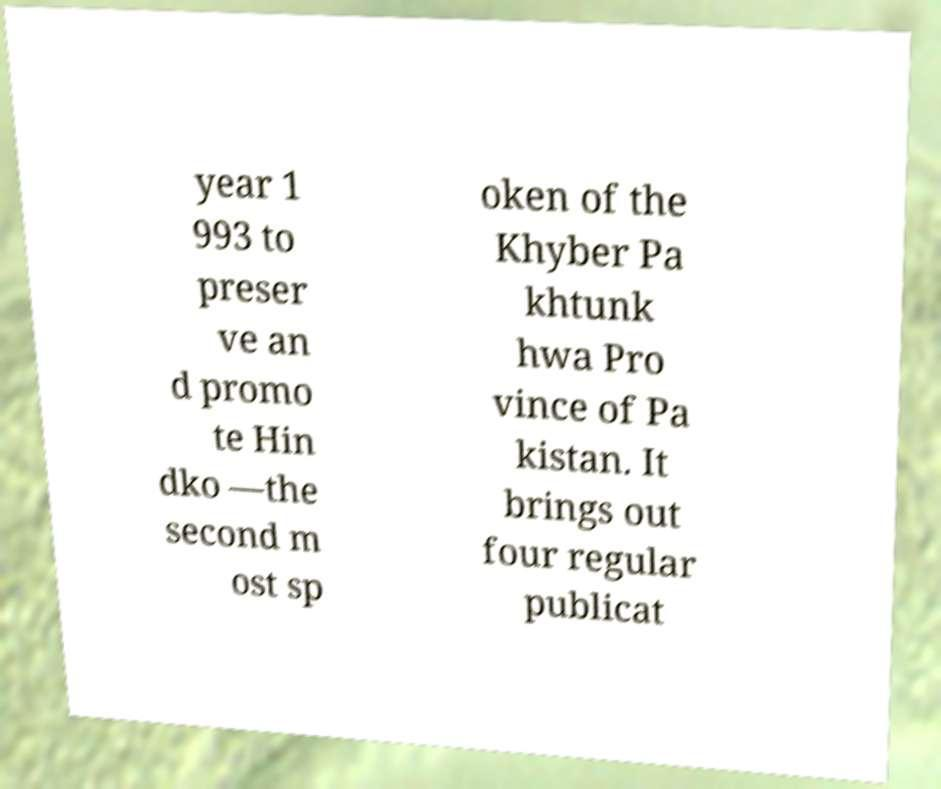Can you read and provide the text displayed in the image?This photo seems to have some interesting text. Can you extract and type it out for me? year 1 993 to preser ve an d promo te Hin dko —the second m ost sp oken of the Khyber Pa khtunk hwa Pro vince of Pa kistan. It brings out four regular publicat 